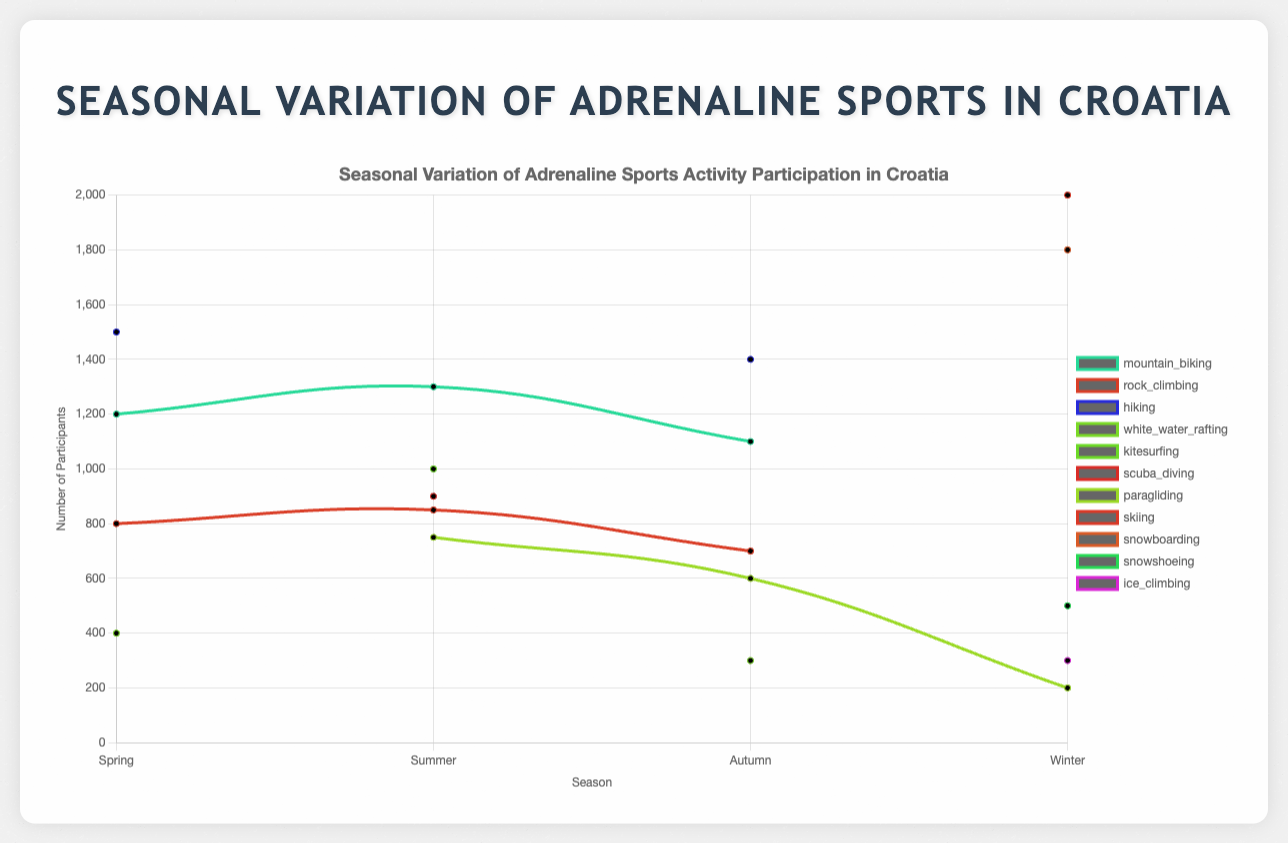Which season has the highest number of participants for mountain biking? Look at the curve for mountain biking and identify the point with the highest number of participants. This occurs in summer.
Answer: Summer How many more participants does skiing have in winter compared to snowboarding in the same season? In winter, skiing has 2000 participants and snowboarding has 1800 participants. The difference is 2000 - 1800 = 200.
Answer: 200 Which activity shows a drop in participants from spring to autumn? Compare the number of participants for each activity between spring and autumn and identify any decreases. Both hiking and rock climbing see a drop in participants.
Answer: Hiking, Rock Climbing Which activity has the most consistent number of participants across all seasons? Examine the fluctuations in participant numbers across four seasons for each activity. Mountain biking shows the least variation with 1200 in spring, 1300 in summer, and 1100 in autumn.
Answer: Mountain Biking What is the average number of participants for paragliding across all seasons? Add the number of participants for paragliding in summer, autumn, and winter and divide by the number of seasons in which it is practiced: (750 + 600 + 200)/3 = 516.67
Answer: 516.67 Which season has the most activities with over 1000 participants? Count the number of activities with more than 1000 participants in each season. Spring has 2, summer has 3, autumn has 1, and winter has 2.
Answer: Summer What is the total number of days per week spent on adrenaline sports activities in spring? Sum the days per week for all activities in spring: 3 (mountain biking) + 2 (rock climbing) + 5 (hiking) + 1 (white water rafting) = 11.
Answer: 11 How does the number of participants in white water rafting change from spring to autumn? Compare the number of participants for white water rafting in spring (400) and autumn (300). The change is 400 - 300 = 100.
Answer: Decreases by 100 Which activity is practiced the most in winter in terms of days per week? Compare the days per week for each activity in winter. Skiing and snowboarding both have 4 days per week.
Answer: Skiing, Snowboarding 